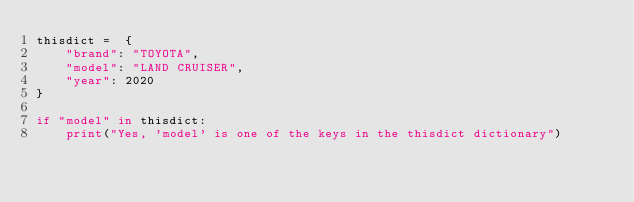Convert code to text. <code><loc_0><loc_0><loc_500><loc_500><_Python_>thisdict =	{
    "brand": "TOYOTA",
    "model": "LAND CRUISER",
    "year": 2020
}

if "model" in thisdict:
    print("Yes, 'model' is one of the keys in the thisdict dictionary") </code> 